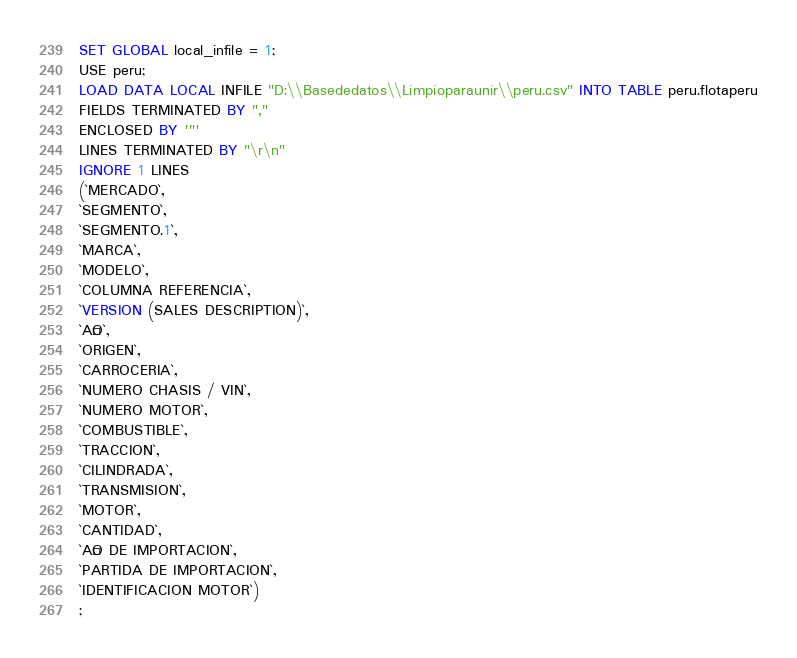<code> <loc_0><loc_0><loc_500><loc_500><_SQL_>SET GLOBAL local_infile = 1;
USE peru;
LOAD DATA LOCAL INFILE "D:\\Basededatos\\Limpioparaunir\\peru.csv" INTO TABLE peru.flotaperu
FIELDS TERMINATED BY ","
ENCLOSED BY '"'
LINES TERMINATED BY "\r\n"
IGNORE 1 LINES
(`MERCADO`,
`SEGMENTO`,
`SEGMENTO.1`,
`MARCA`,
`MODELO`,
`COLUMNA REFERENCIA`,
`VERSION (SALES DESCRIPTION)`,
`AÑO`,
`ORIGEN`,
`CARROCERIA`,
`NUMERO CHASIS / VIN`,
`NUMERO MOTOR`,
`COMBUSTIBLE`,
`TRACCION`,
`CILINDRADA`,
`TRANSMISION`,
`MOTOR`,
`CANTIDAD`,
`AÑO DE IMPORTACION`,
`PARTIDA DE IMPORTACION`,
`IDENTIFICACION MOTOR`)
;
</code> 